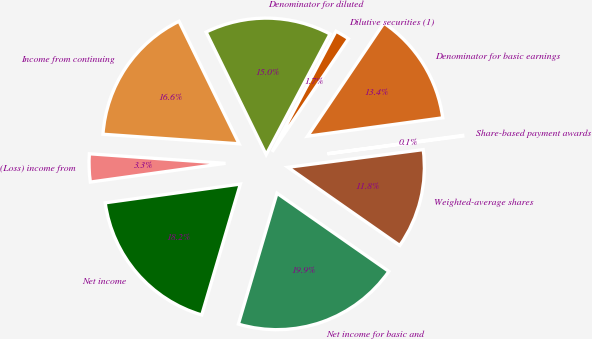Convert chart. <chart><loc_0><loc_0><loc_500><loc_500><pie_chart><fcel>Income from continuing<fcel>(Loss) income from<fcel>Net income<fcel>Net income for basic and<fcel>Weighted-average shares<fcel>Share-based payment awards<fcel>Denominator for basic earnings<fcel>Dilutive securities (1)<fcel>Denominator for diluted<nl><fcel>16.63%<fcel>3.31%<fcel>18.24%<fcel>19.86%<fcel>11.78%<fcel>0.08%<fcel>13.4%<fcel>1.7%<fcel>15.01%<nl></chart> 